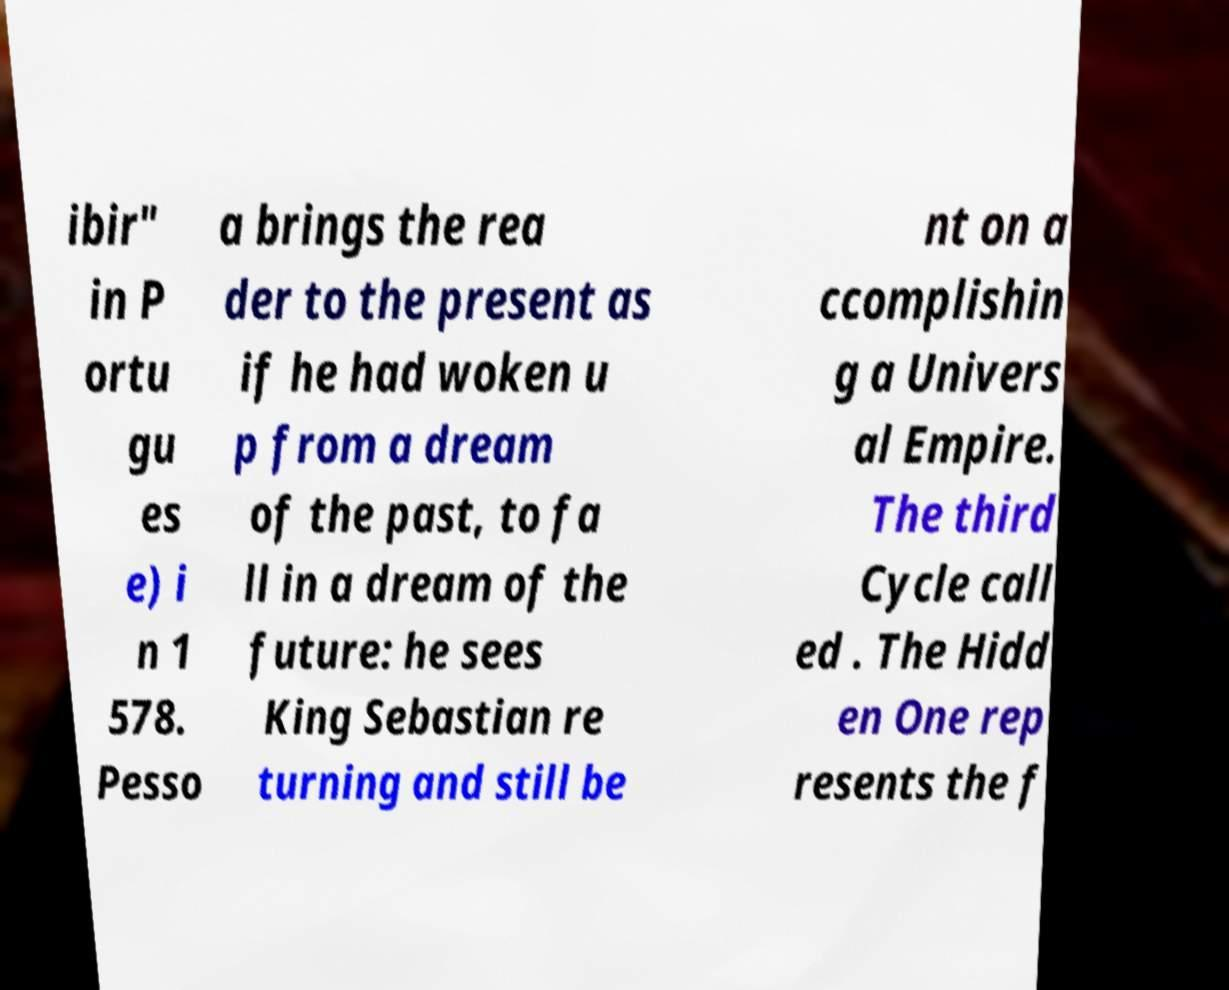Can you read and provide the text displayed in the image?This photo seems to have some interesting text. Can you extract and type it out for me? ibir" in P ortu gu es e) i n 1 578. Pesso a brings the rea der to the present as if he had woken u p from a dream of the past, to fa ll in a dream of the future: he sees King Sebastian re turning and still be nt on a ccomplishin g a Univers al Empire. The third Cycle call ed . The Hidd en One rep resents the f 